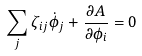Convert formula to latex. <formula><loc_0><loc_0><loc_500><loc_500>\sum _ { j } \zeta _ { i j } \dot { \phi } _ { j } + \frac { \partial A } { \partial \phi _ { i } } = 0</formula> 